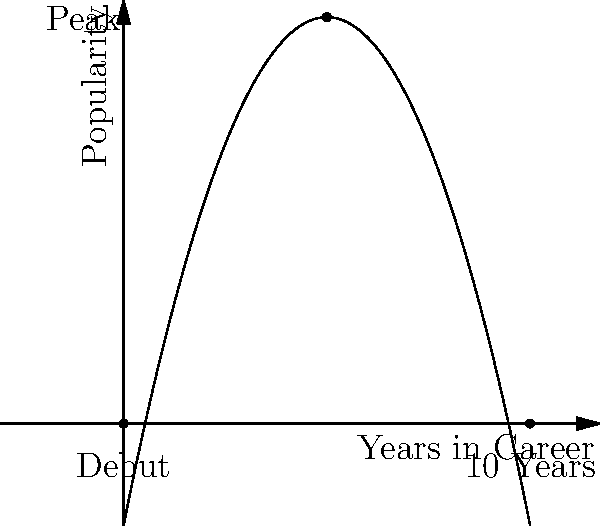An artist's career trajectory can be modeled by the parabola $f(x)=-0.5(x-5)^2+10$, where $x$ represents years into their career and $f(x)$ represents their popularity. At what point in their career does the artist reach peak popularity, and what is the corresponding popularity level? To find the peak of the parabola, we need to follow these steps:

1) The general form of a parabola is $f(x)=a(x-h)^2+k$, where $(h,k)$ is the vertex.

2) Our parabola is in the form $f(x)=-0.5(x-5)^2+10$

3) Comparing this to the general form, we can see that:
   $h=5$ (the x-coordinate of the vertex)
   $k=10$ (the y-coordinate of the vertex)

4) The vertex $(h,k)$ represents the peak of the parabola.

5) Therefore, the artist reaches peak popularity at $x=5$ years into their career.

6) The corresponding popularity level is $f(5)=10$.

Thus, the artist reaches peak popularity 5 years into their career, with a popularity level of 10.
Answer: (5,10) 